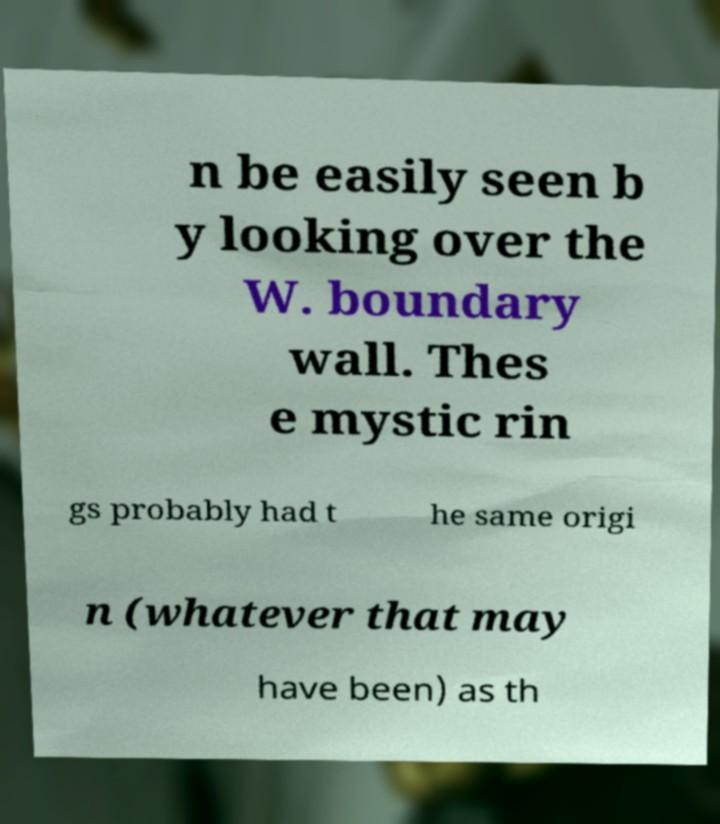Please identify and transcribe the text found in this image. n be easily seen b y looking over the W. boundary wall. Thes e mystic rin gs probably had t he same origi n (whatever that may have been) as th 